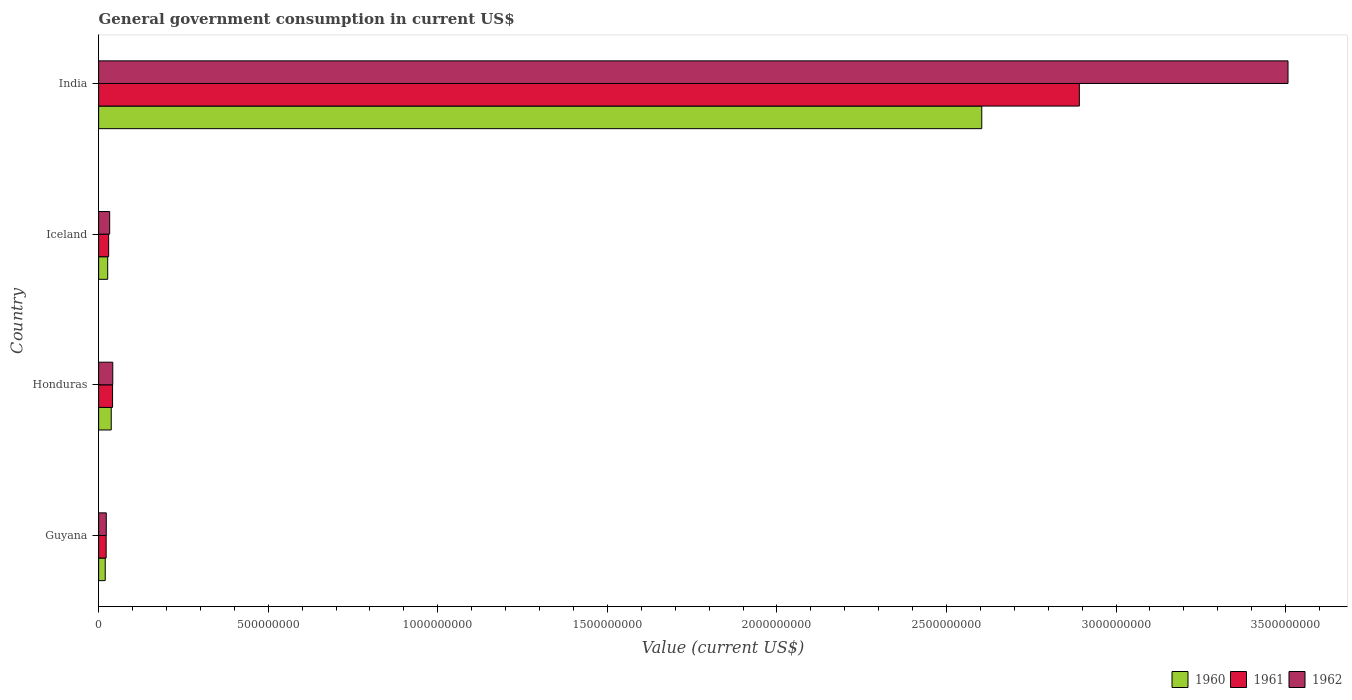Are the number of bars per tick equal to the number of legend labels?
Provide a short and direct response. Yes. Are the number of bars on each tick of the Y-axis equal?
Your response must be concise. Yes. How many bars are there on the 2nd tick from the top?
Provide a succinct answer. 3. How many bars are there on the 1st tick from the bottom?
Your answer should be very brief. 3. What is the label of the 3rd group of bars from the top?
Provide a succinct answer. Honduras. In how many cases, is the number of bars for a given country not equal to the number of legend labels?
Your answer should be very brief. 0. What is the government conusmption in 1960 in India?
Give a very brief answer. 2.60e+09. Across all countries, what is the maximum government conusmption in 1960?
Offer a terse response. 2.60e+09. Across all countries, what is the minimum government conusmption in 1962?
Give a very brief answer. 2.25e+07. In which country was the government conusmption in 1961 maximum?
Offer a terse response. India. In which country was the government conusmption in 1962 minimum?
Offer a very short reply. Guyana. What is the total government conusmption in 1960 in the graph?
Offer a terse response. 2.69e+09. What is the difference between the government conusmption in 1962 in Guyana and that in Honduras?
Ensure brevity in your answer.  -1.91e+07. What is the difference between the government conusmption in 1960 in Guyana and the government conusmption in 1961 in Iceland?
Give a very brief answer. -1.00e+07. What is the average government conusmption in 1960 per country?
Ensure brevity in your answer.  6.72e+08. What is the difference between the government conusmption in 1962 and government conusmption in 1960 in India?
Your answer should be very brief. 9.03e+08. What is the ratio of the government conusmption in 1960 in Honduras to that in Iceland?
Your response must be concise. 1.39. Is the government conusmption in 1961 in Guyana less than that in Iceland?
Your answer should be very brief. Yes. Is the difference between the government conusmption in 1962 in Guyana and Honduras greater than the difference between the government conusmption in 1960 in Guyana and Honduras?
Keep it short and to the point. No. What is the difference between the highest and the second highest government conusmption in 1961?
Provide a succinct answer. 2.85e+09. What is the difference between the highest and the lowest government conusmption in 1962?
Ensure brevity in your answer.  3.48e+09. In how many countries, is the government conusmption in 1960 greater than the average government conusmption in 1960 taken over all countries?
Provide a succinct answer. 1. Is the sum of the government conusmption in 1961 in Honduras and India greater than the maximum government conusmption in 1960 across all countries?
Your answer should be very brief. Yes. What does the 3rd bar from the bottom in India represents?
Your answer should be compact. 1962. How many countries are there in the graph?
Give a very brief answer. 4. How are the legend labels stacked?
Give a very brief answer. Horizontal. What is the title of the graph?
Keep it short and to the point. General government consumption in current US$. Does "1999" appear as one of the legend labels in the graph?
Ensure brevity in your answer.  No. What is the label or title of the X-axis?
Ensure brevity in your answer.  Value (current US$). What is the Value (current US$) of 1960 in Guyana?
Offer a terse response. 1.95e+07. What is the Value (current US$) of 1961 in Guyana?
Offer a terse response. 2.22e+07. What is the Value (current US$) of 1962 in Guyana?
Offer a terse response. 2.25e+07. What is the Value (current US$) in 1960 in Honduras?
Offer a terse response. 3.72e+07. What is the Value (current US$) of 1961 in Honduras?
Ensure brevity in your answer.  4.10e+07. What is the Value (current US$) of 1962 in Honduras?
Give a very brief answer. 4.16e+07. What is the Value (current US$) in 1960 in Iceland?
Ensure brevity in your answer.  2.68e+07. What is the Value (current US$) in 1961 in Iceland?
Give a very brief answer. 2.95e+07. What is the Value (current US$) of 1962 in Iceland?
Your answer should be very brief. 3.25e+07. What is the Value (current US$) of 1960 in India?
Offer a terse response. 2.60e+09. What is the Value (current US$) in 1961 in India?
Give a very brief answer. 2.89e+09. What is the Value (current US$) of 1962 in India?
Give a very brief answer. 3.51e+09. Across all countries, what is the maximum Value (current US$) in 1960?
Keep it short and to the point. 2.60e+09. Across all countries, what is the maximum Value (current US$) in 1961?
Your answer should be very brief. 2.89e+09. Across all countries, what is the maximum Value (current US$) of 1962?
Provide a succinct answer. 3.51e+09. Across all countries, what is the minimum Value (current US$) in 1960?
Keep it short and to the point. 1.95e+07. Across all countries, what is the minimum Value (current US$) in 1961?
Provide a succinct answer. 2.22e+07. Across all countries, what is the minimum Value (current US$) of 1962?
Your answer should be compact. 2.25e+07. What is the total Value (current US$) of 1960 in the graph?
Ensure brevity in your answer.  2.69e+09. What is the total Value (current US$) in 1961 in the graph?
Ensure brevity in your answer.  2.98e+09. What is the total Value (current US$) in 1962 in the graph?
Provide a short and direct response. 3.60e+09. What is the difference between the Value (current US$) in 1960 in Guyana and that in Honduras?
Ensure brevity in your answer.  -1.77e+07. What is the difference between the Value (current US$) of 1961 in Guyana and that in Honduras?
Your answer should be very brief. -1.89e+07. What is the difference between the Value (current US$) of 1962 in Guyana and that in Honduras?
Your answer should be compact. -1.91e+07. What is the difference between the Value (current US$) of 1960 in Guyana and that in Iceland?
Your answer should be compact. -7.28e+06. What is the difference between the Value (current US$) of 1961 in Guyana and that in Iceland?
Make the answer very short. -7.36e+06. What is the difference between the Value (current US$) of 1962 in Guyana and that in Iceland?
Your response must be concise. -1.00e+07. What is the difference between the Value (current US$) of 1960 in Guyana and that in India?
Make the answer very short. -2.58e+09. What is the difference between the Value (current US$) of 1961 in Guyana and that in India?
Provide a succinct answer. -2.87e+09. What is the difference between the Value (current US$) of 1962 in Guyana and that in India?
Your response must be concise. -3.48e+09. What is the difference between the Value (current US$) of 1960 in Honduras and that in Iceland?
Provide a succinct answer. 1.04e+07. What is the difference between the Value (current US$) in 1961 in Honduras and that in Iceland?
Your answer should be compact. 1.15e+07. What is the difference between the Value (current US$) in 1962 in Honduras and that in Iceland?
Ensure brevity in your answer.  9.12e+06. What is the difference between the Value (current US$) of 1960 in Honduras and that in India?
Your answer should be compact. -2.57e+09. What is the difference between the Value (current US$) of 1961 in Honduras and that in India?
Provide a succinct answer. -2.85e+09. What is the difference between the Value (current US$) in 1962 in Honduras and that in India?
Provide a short and direct response. -3.47e+09. What is the difference between the Value (current US$) of 1960 in Iceland and that in India?
Your answer should be compact. -2.58e+09. What is the difference between the Value (current US$) in 1961 in Iceland and that in India?
Give a very brief answer. -2.86e+09. What is the difference between the Value (current US$) of 1962 in Iceland and that in India?
Offer a very short reply. -3.47e+09. What is the difference between the Value (current US$) of 1960 in Guyana and the Value (current US$) of 1961 in Honduras?
Provide a succinct answer. -2.16e+07. What is the difference between the Value (current US$) of 1960 in Guyana and the Value (current US$) of 1962 in Honduras?
Your answer should be compact. -2.22e+07. What is the difference between the Value (current US$) in 1961 in Guyana and the Value (current US$) in 1962 in Honduras?
Ensure brevity in your answer.  -1.95e+07. What is the difference between the Value (current US$) of 1960 in Guyana and the Value (current US$) of 1961 in Iceland?
Provide a short and direct response. -1.00e+07. What is the difference between the Value (current US$) of 1960 in Guyana and the Value (current US$) of 1962 in Iceland?
Your response must be concise. -1.30e+07. What is the difference between the Value (current US$) in 1961 in Guyana and the Value (current US$) in 1962 in Iceland?
Ensure brevity in your answer.  -1.04e+07. What is the difference between the Value (current US$) of 1960 in Guyana and the Value (current US$) of 1961 in India?
Offer a terse response. -2.87e+09. What is the difference between the Value (current US$) in 1960 in Guyana and the Value (current US$) in 1962 in India?
Provide a succinct answer. -3.49e+09. What is the difference between the Value (current US$) in 1961 in Guyana and the Value (current US$) in 1962 in India?
Offer a very short reply. -3.48e+09. What is the difference between the Value (current US$) of 1960 in Honduras and the Value (current US$) of 1961 in Iceland?
Your response must be concise. 7.62e+06. What is the difference between the Value (current US$) of 1960 in Honduras and the Value (current US$) of 1962 in Iceland?
Give a very brief answer. 4.62e+06. What is the difference between the Value (current US$) of 1961 in Honduras and the Value (current US$) of 1962 in Iceland?
Ensure brevity in your answer.  8.52e+06. What is the difference between the Value (current US$) in 1960 in Honduras and the Value (current US$) in 1961 in India?
Offer a very short reply. -2.85e+09. What is the difference between the Value (current US$) of 1960 in Honduras and the Value (current US$) of 1962 in India?
Your answer should be compact. -3.47e+09. What is the difference between the Value (current US$) of 1961 in Honduras and the Value (current US$) of 1962 in India?
Offer a very short reply. -3.47e+09. What is the difference between the Value (current US$) of 1960 in Iceland and the Value (current US$) of 1961 in India?
Your answer should be compact. -2.86e+09. What is the difference between the Value (current US$) of 1960 in Iceland and the Value (current US$) of 1962 in India?
Your answer should be compact. -3.48e+09. What is the difference between the Value (current US$) of 1961 in Iceland and the Value (current US$) of 1962 in India?
Give a very brief answer. -3.48e+09. What is the average Value (current US$) in 1960 per country?
Ensure brevity in your answer.  6.72e+08. What is the average Value (current US$) in 1961 per country?
Offer a very short reply. 7.46e+08. What is the average Value (current US$) in 1962 per country?
Your answer should be compact. 9.01e+08. What is the difference between the Value (current US$) in 1960 and Value (current US$) in 1961 in Guyana?
Keep it short and to the point. -2.68e+06. What is the difference between the Value (current US$) in 1960 and Value (current US$) in 1962 in Guyana?
Your answer should be compact. -3.03e+06. What is the difference between the Value (current US$) of 1961 and Value (current US$) of 1962 in Guyana?
Keep it short and to the point. -3.50e+05. What is the difference between the Value (current US$) of 1960 and Value (current US$) of 1961 in Honduras?
Provide a succinct answer. -3.90e+06. What is the difference between the Value (current US$) of 1960 and Value (current US$) of 1962 in Honduras?
Offer a very short reply. -4.50e+06. What is the difference between the Value (current US$) of 1961 and Value (current US$) of 1962 in Honduras?
Provide a succinct answer. -6.00e+05. What is the difference between the Value (current US$) in 1960 and Value (current US$) in 1961 in Iceland?
Offer a very short reply. -2.77e+06. What is the difference between the Value (current US$) in 1960 and Value (current US$) in 1962 in Iceland?
Provide a succinct answer. -5.77e+06. What is the difference between the Value (current US$) of 1961 and Value (current US$) of 1962 in Iceland?
Provide a succinct answer. -3.00e+06. What is the difference between the Value (current US$) in 1960 and Value (current US$) in 1961 in India?
Your response must be concise. -2.88e+08. What is the difference between the Value (current US$) in 1960 and Value (current US$) in 1962 in India?
Keep it short and to the point. -9.03e+08. What is the difference between the Value (current US$) in 1961 and Value (current US$) in 1962 in India?
Your answer should be very brief. -6.15e+08. What is the ratio of the Value (current US$) in 1960 in Guyana to that in Honduras?
Make the answer very short. 0.52. What is the ratio of the Value (current US$) of 1961 in Guyana to that in Honduras?
Provide a short and direct response. 0.54. What is the ratio of the Value (current US$) of 1962 in Guyana to that in Honduras?
Give a very brief answer. 0.54. What is the ratio of the Value (current US$) in 1960 in Guyana to that in Iceland?
Provide a short and direct response. 0.73. What is the ratio of the Value (current US$) of 1961 in Guyana to that in Iceland?
Offer a terse response. 0.75. What is the ratio of the Value (current US$) in 1962 in Guyana to that in Iceland?
Your answer should be very brief. 0.69. What is the ratio of the Value (current US$) of 1960 in Guyana to that in India?
Ensure brevity in your answer.  0.01. What is the ratio of the Value (current US$) in 1961 in Guyana to that in India?
Your answer should be very brief. 0.01. What is the ratio of the Value (current US$) of 1962 in Guyana to that in India?
Provide a succinct answer. 0.01. What is the ratio of the Value (current US$) of 1960 in Honduras to that in Iceland?
Ensure brevity in your answer.  1.39. What is the ratio of the Value (current US$) in 1961 in Honduras to that in Iceland?
Your answer should be very brief. 1.39. What is the ratio of the Value (current US$) of 1962 in Honduras to that in Iceland?
Keep it short and to the point. 1.28. What is the ratio of the Value (current US$) of 1960 in Honduras to that in India?
Your answer should be compact. 0.01. What is the ratio of the Value (current US$) in 1961 in Honduras to that in India?
Provide a short and direct response. 0.01. What is the ratio of the Value (current US$) of 1962 in Honduras to that in India?
Provide a short and direct response. 0.01. What is the ratio of the Value (current US$) in 1960 in Iceland to that in India?
Keep it short and to the point. 0.01. What is the ratio of the Value (current US$) in 1961 in Iceland to that in India?
Your answer should be very brief. 0.01. What is the ratio of the Value (current US$) in 1962 in Iceland to that in India?
Make the answer very short. 0.01. What is the difference between the highest and the second highest Value (current US$) in 1960?
Provide a short and direct response. 2.57e+09. What is the difference between the highest and the second highest Value (current US$) of 1961?
Ensure brevity in your answer.  2.85e+09. What is the difference between the highest and the second highest Value (current US$) in 1962?
Make the answer very short. 3.47e+09. What is the difference between the highest and the lowest Value (current US$) in 1960?
Your response must be concise. 2.58e+09. What is the difference between the highest and the lowest Value (current US$) in 1961?
Offer a terse response. 2.87e+09. What is the difference between the highest and the lowest Value (current US$) of 1962?
Give a very brief answer. 3.48e+09. 